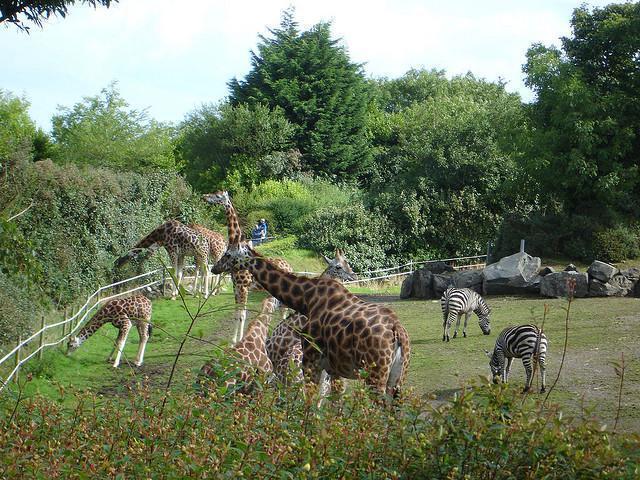How many different species of animals are grazing in the savannah?
From the following four choices, select the correct answer to address the question.
Options: Eight, two, one, seven. Two. 